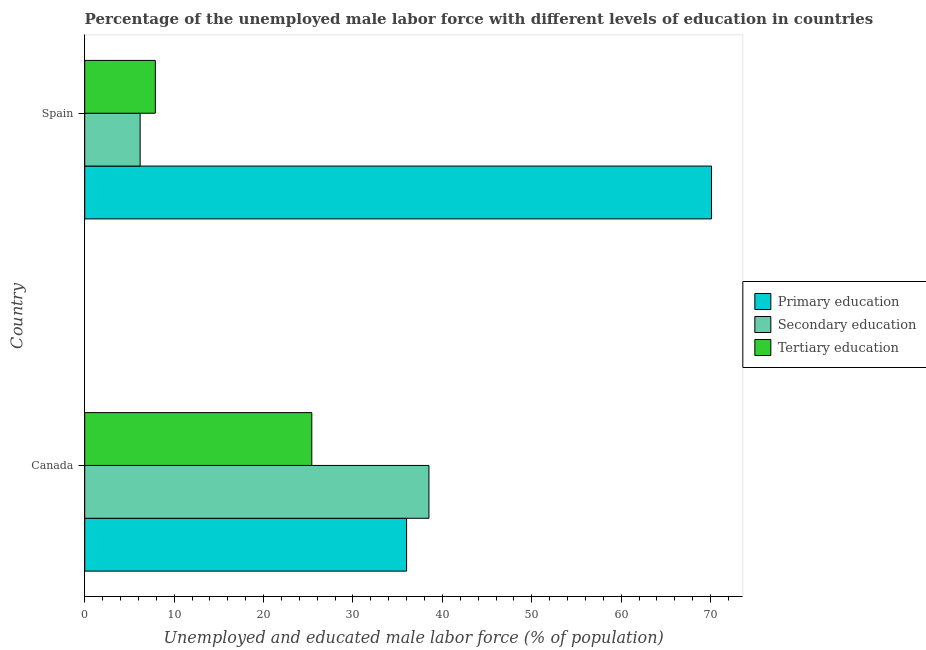How many different coloured bars are there?
Provide a succinct answer. 3. Are the number of bars per tick equal to the number of legend labels?
Offer a very short reply. Yes. Are the number of bars on each tick of the Y-axis equal?
Offer a very short reply. Yes. What is the label of the 1st group of bars from the top?
Your answer should be compact. Spain. In how many cases, is the number of bars for a given country not equal to the number of legend labels?
Offer a very short reply. 0. What is the percentage of male labor force who received tertiary education in Spain?
Offer a very short reply. 7.9. Across all countries, what is the maximum percentage of male labor force who received primary education?
Provide a succinct answer. 70.1. Across all countries, what is the minimum percentage of male labor force who received secondary education?
Provide a succinct answer. 6.2. What is the total percentage of male labor force who received primary education in the graph?
Offer a very short reply. 106.1. What is the difference between the percentage of male labor force who received primary education in Canada and that in Spain?
Provide a succinct answer. -34.1. What is the difference between the percentage of male labor force who received tertiary education in Canada and the percentage of male labor force who received secondary education in Spain?
Your answer should be very brief. 19.2. What is the average percentage of male labor force who received tertiary education per country?
Your answer should be very brief. 16.65. What is the difference between the percentage of male labor force who received primary education and percentage of male labor force who received secondary education in Spain?
Offer a very short reply. 63.9. In how many countries, is the percentage of male labor force who received tertiary education greater than 54 %?
Make the answer very short. 0. What is the ratio of the percentage of male labor force who received secondary education in Canada to that in Spain?
Your response must be concise. 6.21. Is the percentage of male labor force who received primary education in Canada less than that in Spain?
Your answer should be very brief. Yes. What does the 2nd bar from the top in Canada represents?
Provide a succinct answer. Secondary education. What does the 2nd bar from the bottom in Canada represents?
Give a very brief answer. Secondary education. Is it the case that in every country, the sum of the percentage of male labor force who received primary education and percentage of male labor force who received secondary education is greater than the percentage of male labor force who received tertiary education?
Ensure brevity in your answer.  Yes. How many bars are there?
Your response must be concise. 6. Are all the bars in the graph horizontal?
Offer a terse response. Yes. What is the difference between two consecutive major ticks on the X-axis?
Ensure brevity in your answer.  10. Are the values on the major ticks of X-axis written in scientific E-notation?
Provide a succinct answer. No. Does the graph contain grids?
Your response must be concise. No. Where does the legend appear in the graph?
Provide a short and direct response. Center right. How many legend labels are there?
Offer a terse response. 3. What is the title of the graph?
Offer a very short reply. Percentage of the unemployed male labor force with different levels of education in countries. Does "Travel services" appear as one of the legend labels in the graph?
Offer a very short reply. No. What is the label or title of the X-axis?
Your answer should be very brief. Unemployed and educated male labor force (% of population). What is the label or title of the Y-axis?
Your answer should be very brief. Country. What is the Unemployed and educated male labor force (% of population) in Primary education in Canada?
Offer a terse response. 36. What is the Unemployed and educated male labor force (% of population) in Secondary education in Canada?
Keep it short and to the point. 38.5. What is the Unemployed and educated male labor force (% of population) of Tertiary education in Canada?
Offer a very short reply. 25.4. What is the Unemployed and educated male labor force (% of population) in Primary education in Spain?
Your response must be concise. 70.1. What is the Unemployed and educated male labor force (% of population) of Secondary education in Spain?
Ensure brevity in your answer.  6.2. What is the Unemployed and educated male labor force (% of population) in Tertiary education in Spain?
Provide a succinct answer. 7.9. Across all countries, what is the maximum Unemployed and educated male labor force (% of population) of Primary education?
Your answer should be compact. 70.1. Across all countries, what is the maximum Unemployed and educated male labor force (% of population) in Secondary education?
Ensure brevity in your answer.  38.5. Across all countries, what is the maximum Unemployed and educated male labor force (% of population) of Tertiary education?
Keep it short and to the point. 25.4. Across all countries, what is the minimum Unemployed and educated male labor force (% of population) of Secondary education?
Your response must be concise. 6.2. Across all countries, what is the minimum Unemployed and educated male labor force (% of population) of Tertiary education?
Your answer should be compact. 7.9. What is the total Unemployed and educated male labor force (% of population) in Primary education in the graph?
Your answer should be compact. 106.1. What is the total Unemployed and educated male labor force (% of population) of Secondary education in the graph?
Provide a short and direct response. 44.7. What is the total Unemployed and educated male labor force (% of population) in Tertiary education in the graph?
Make the answer very short. 33.3. What is the difference between the Unemployed and educated male labor force (% of population) in Primary education in Canada and that in Spain?
Provide a short and direct response. -34.1. What is the difference between the Unemployed and educated male labor force (% of population) in Secondary education in Canada and that in Spain?
Keep it short and to the point. 32.3. What is the difference between the Unemployed and educated male labor force (% of population) in Primary education in Canada and the Unemployed and educated male labor force (% of population) in Secondary education in Spain?
Ensure brevity in your answer.  29.8. What is the difference between the Unemployed and educated male labor force (% of population) in Primary education in Canada and the Unemployed and educated male labor force (% of population) in Tertiary education in Spain?
Provide a short and direct response. 28.1. What is the difference between the Unemployed and educated male labor force (% of population) of Secondary education in Canada and the Unemployed and educated male labor force (% of population) of Tertiary education in Spain?
Offer a very short reply. 30.6. What is the average Unemployed and educated male labor force (% of population) of Primary education per country?
Your response must be concise. 53.05. What is the average Unemployed and educated male labor force (% of population) of Secondary education per country?
Offer a terse response. 22.35. What is the average Unemployed and educated male labor force (% of population) of Tertiary education per country?
Keep it short and to the point. 16.65. What is the difference between the Unemployed and educated male labor force (% of population) of Primary education and Unemployed and educated male labor force (% of population) of Tertiary education in Canada?
Provide a succinct answer. 10.6. What is the difference between the Unemployed and educated male labor force (% of population) in Primary education and Unemployed and educated male labor force (% of population) in Secondary education in Spain?
Provide a short and direct response. 63.9. What is the difference between the Unemployed and educated male labor force (% of population) in Primary education and Unemployed and educated male labor force (% of population) in Tertiary education in Spain?
Make the answer very short. 62.2. What is the difference between the Unemployed and educated male labor force (% of population) in Secondary education and Unemployed and educated male labor force (% of population) in Tertiary education in Spain?
Ensure brevity in your answer.  -1.7. What is the ratio of the Unemployed and educated male labor force (% of population) in Primary education in Canada to that in Spain?
Ensure brevity in your answer.  0.51. What is the ratio of the Unemployed and educated male labor force (% of population) of Secondary education in Canada to that in Spain?
Your answer should be compact. 6.21. What is the ratio of the Unemployed and educated male labor force (% of population) of Tertiary education in Canada to that in Spain?
Give a very brief answer. 3.22. What is the difference between the highest and the second highest Unemployed and educated male labor force (% of population) of Primary education?
Your answer should be very brief. 34.1. What is the difference between the highest and the second highest Unemployed and educated male labor force (% of population) of Secondary education?
Offer a terse response. 32.3. What is the difference between the highest and the second highest Unemployed and educated male labor force (% of population) of Tertiary education?
Provide a short and direct response. 17.5. What is the difference between the highest and the lowest Unemployed and educated male labor force (% of population) of Primary education?
Offer a terse response. 34.1. What is the difference between the highest and the lowest Unemployed and educated male labor force (% of population) of Secondary education?
Make the answer very short. 32.3. What is the difference between the highest and the lowest Unemployed and educated male labor force (% of population) of Tertiary education?
Offer a very short reply. 17.5. 